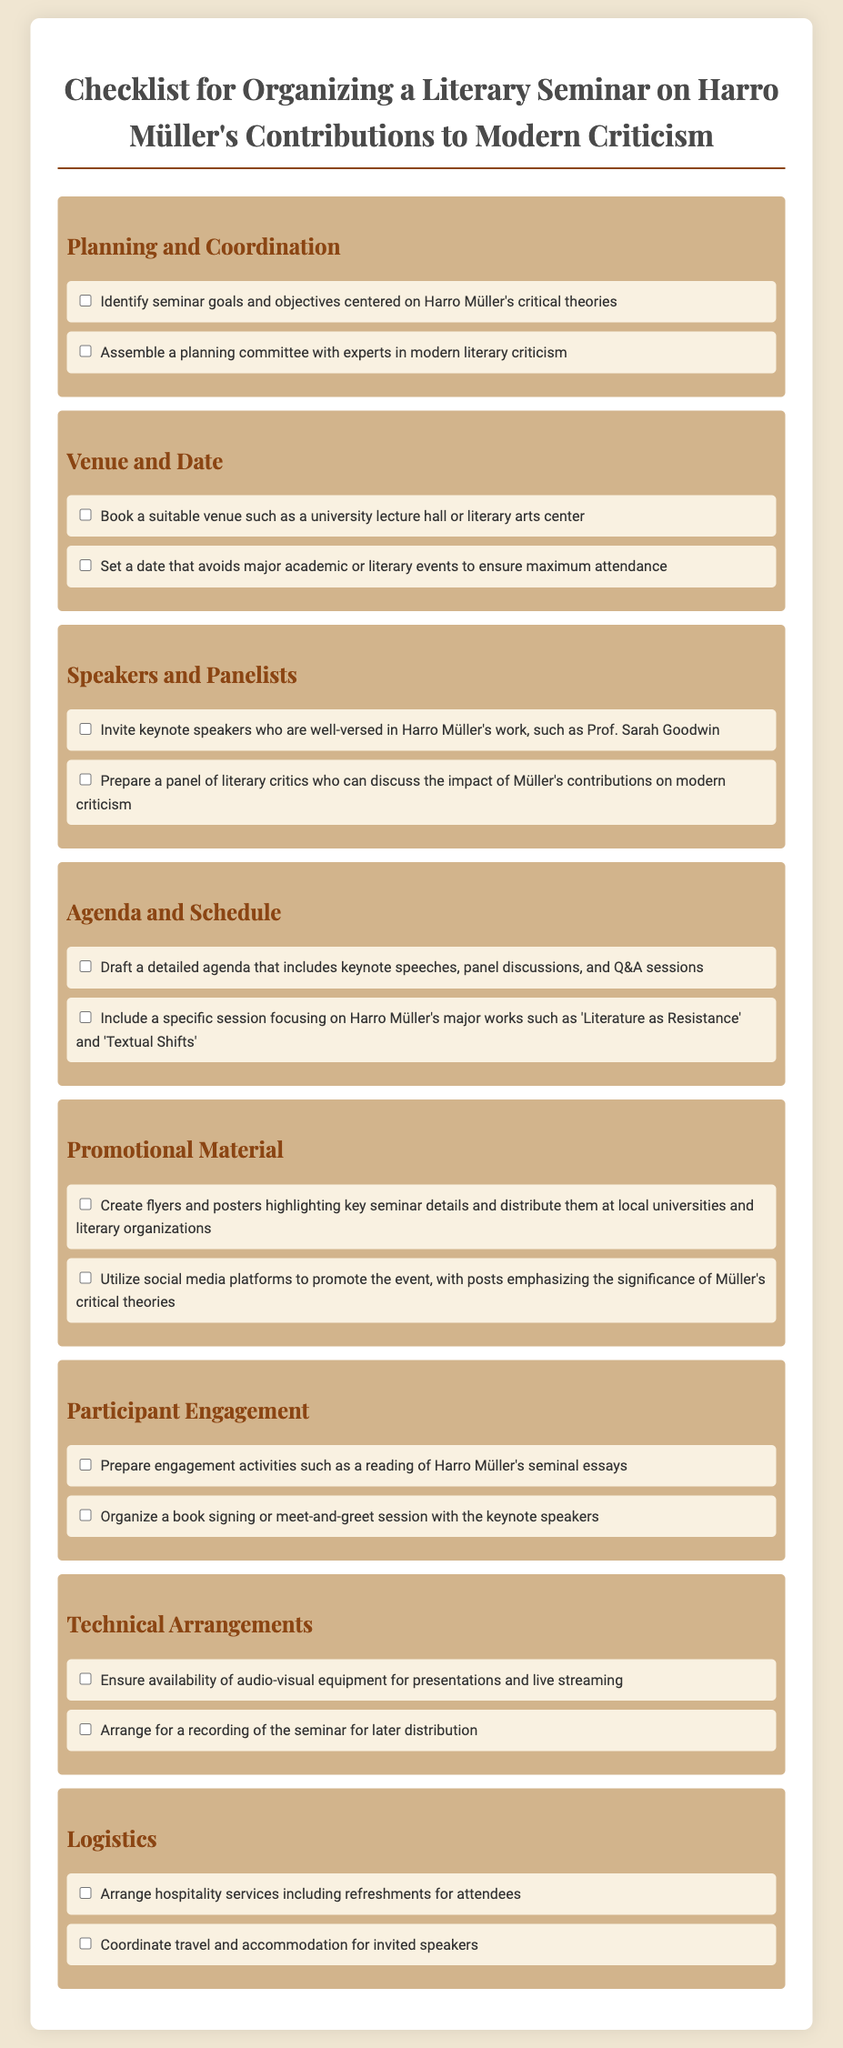What is the title of the checklist? The title of the checklist is stated at the top of the document.
Answer: Checklist for Organizing a Literary Seminar on Harro Müller's Contributions to Modern Criticism How many categories are included in the checklist? The checklist features a total of seven distinct categories outlined in the document.
Answer: Seven Who is a suggested keynote speaker for the seminar? The document mentions a specific individual who can be invited as a keynote speaker.
Answer: Prof. Sarah Goodwin What type of session focuses specifically on Harro Müller's major works? The document specifies a session dedicated to discussing particular works by Harro Müller.
Answer: Specific session What is one of the engagement activities suggested in the checklist? The checklist includes options for activities to engage participants during the seminar.
Answer: Reading of Harro Müller's seminal essays What is the purpose of booking a venue according to the checklist? The checklist highlights the need to arrange a venue that fits the requirements of the seminar.
Answer: Suitable venue How should the seminar be promoted according to the document? The checklist provides methods on how to create awareness for the seminar event.
Answer: Social media platforms What arrangements need to be made for the invited speakers? The document outlines specific logistics that need to be coordinated for key participants.
Answer: Travel and accommodation 